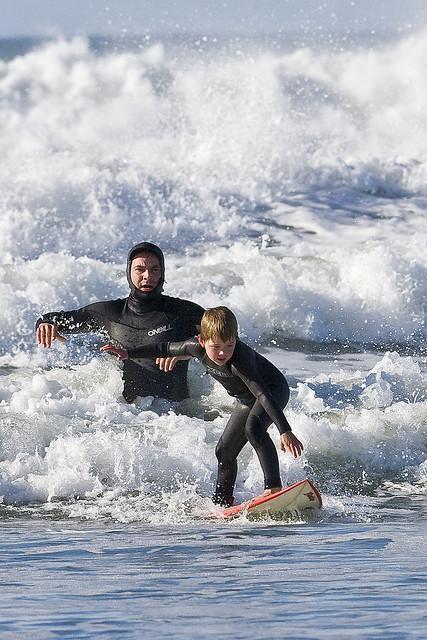Which surfer is more experienced?
Choose the right answer and clarify with the format: 'Answer: answer
Rationale: rationale.'
Options: Larger one, smaller, same, elderly lady. Answer: larger one.
Rationale: The adult likely has more skill than the child and possibly teaching the child. 